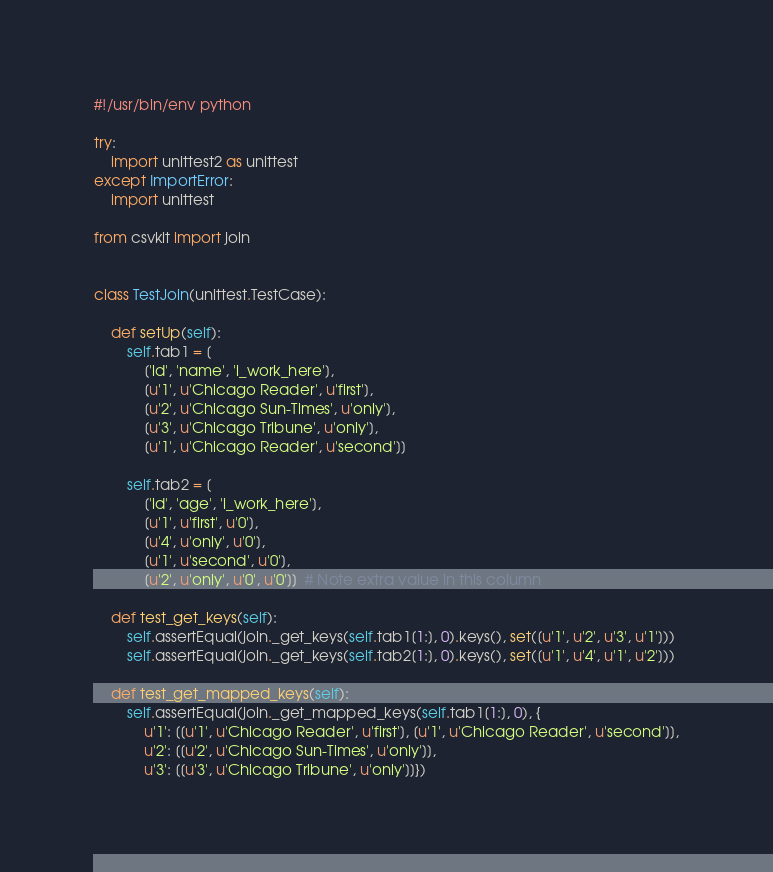Convert code to text. <code><loc_0><loc_0><loc_500><loc_500><_Python_>#!/usr/bin/env python

try:
    import unittest2 as unittest
except ImportError:
    import unittest

from csvkit import join


class TestJoin(unittest.TestCase):

    def setUp(self):
        self.tab1 = [
            ['id', 'name', 'i_work_here'],
            [u'1', u'Chicago Reader', u'first'],
            [u'2', u'Chicago Sun-Times', u'only'],
            [u'3', u'Chicago Tribune', u'only'],
            [u'1', u'Chicago Reader', u'second']]

        self.tab2 = [
            ['id', 'age', 'i_work_here'],
            [u'1', u'first', u'0'],
            [u'4', u'only', u'0'],
            [u'1', u'second', u'0'],
            [u'2', u'only', u'0', u'0']]  # Note extra value in this column

    def test_get_keys(self):
        self.assertEqual(join._get_keys(self.tab1[1:], 0).keys(), set([u'1', u'2', u'3', u'1']))
        self.assertEqual(join._get_keys(self.tab2[1:], 0).keys(), set([u'1', u'4', u'1', u'2']))

    def test_get_mapped_keys(self):
        self.assertEqual(join._get_mapped_keys(self.tab1[1:], 0), {
            u'1': [[u'1', u'Chicago Reader', u'first'], [u'1', u'Chicago Reader', u'second']],
            u'2': [[u'2', u'Chicago Sun-Times', u'only']],
            u'3': [[u'3', u'Chicago Tribune', u'only']]})
</code> 